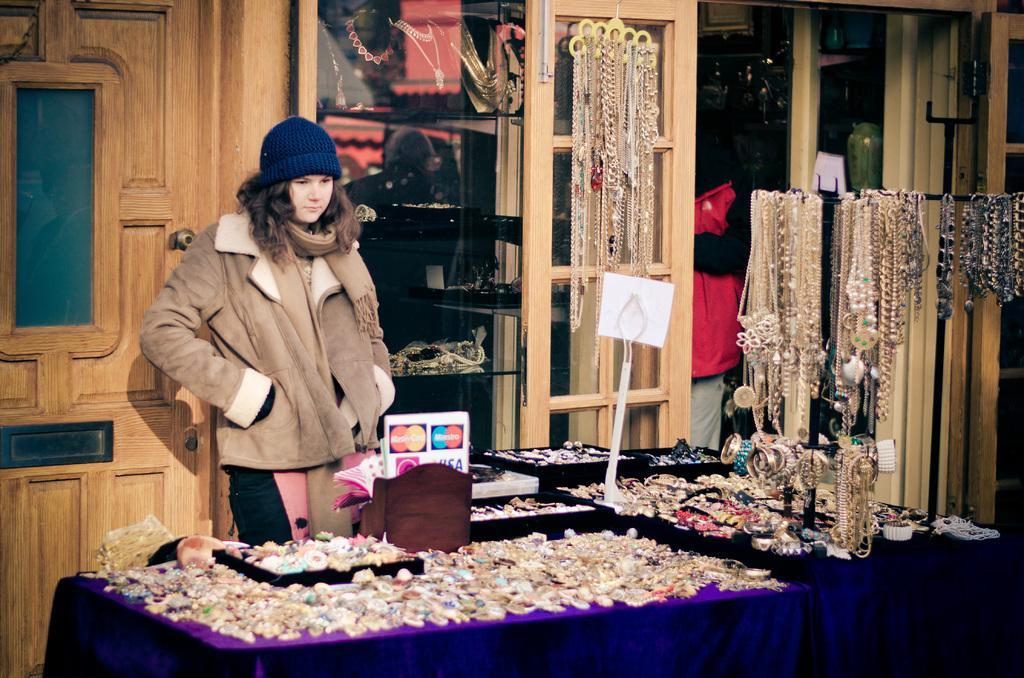Could you give a brief overview of what you see in this image? There is a woman standing in front of few Jewellery items and there are few jewels hanging to a stand in the right corner. 